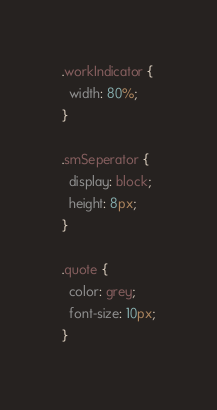<code> <loc_0><loc_0><loc_500><loc_500><_CSS_>
.workIndicator {
  width: 80%;
}

.smSeperator {
  display: block;
  height: 8px;
}

.quote {
  color: grey;
  font-size: 10px;
}
</code> 